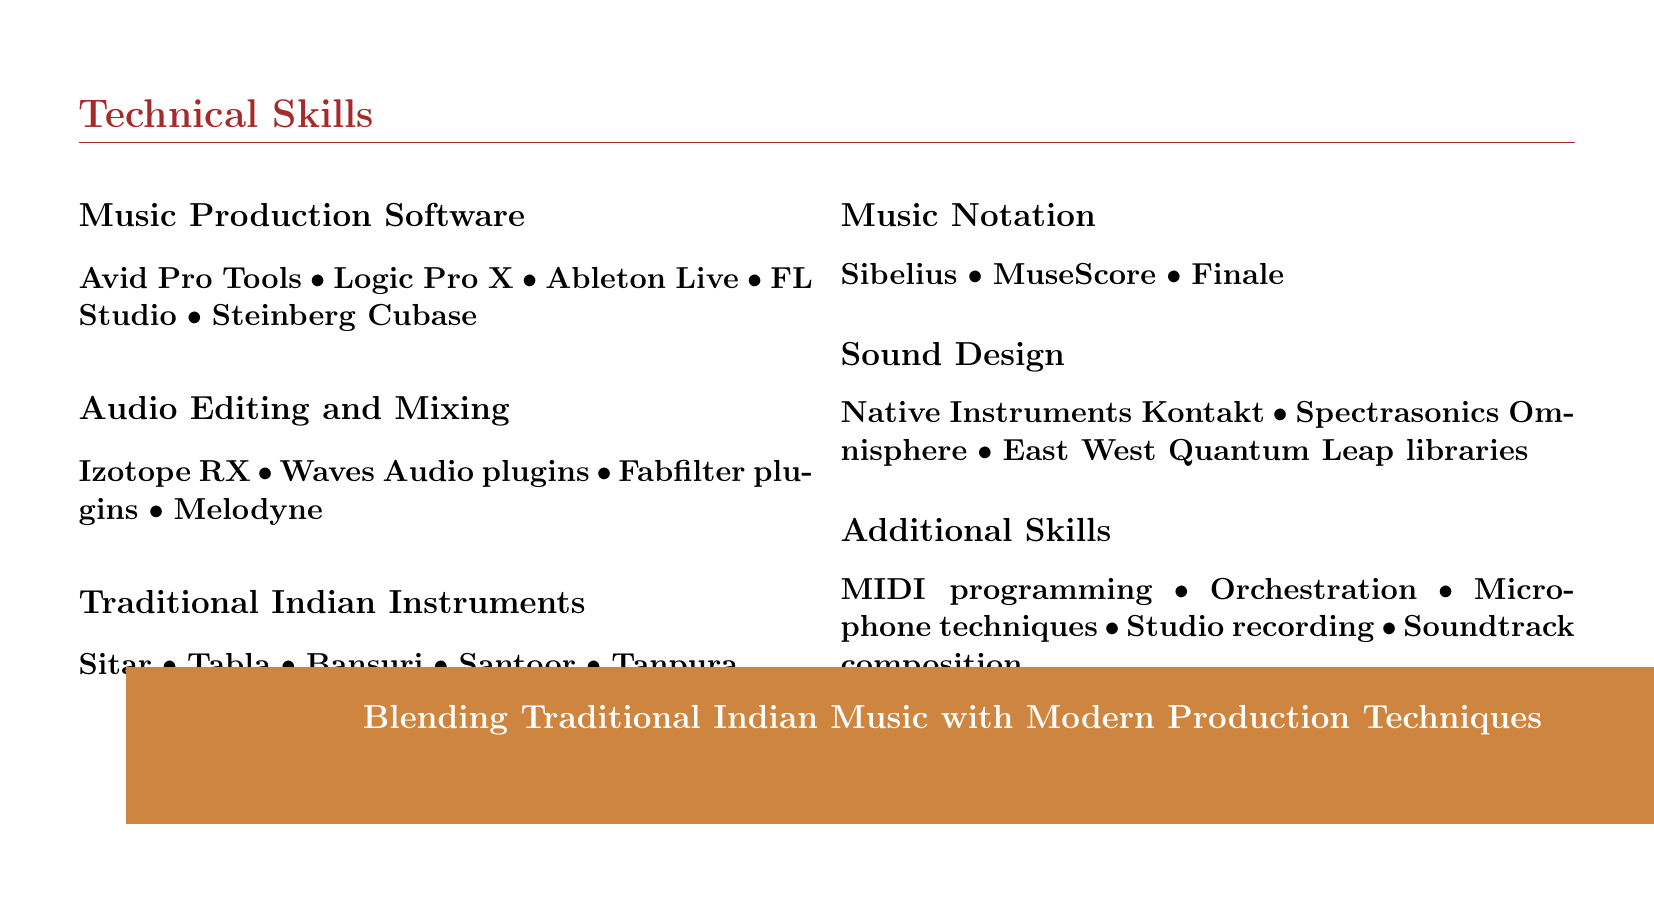what is the title of the document? The title is identified at the top of the document and describes the professional role of the individual.
Answer: Movie Soundtrack Producer how many categories of technical skills are listed? The number of categories is given in the technical skills section of the document.
Answer: 6 which software is mentioned under Music Production Software? This information is found under the Music Production Software section of the technical skills.
Answer: Avid Pro Tools, Logic Pro X, Ableton Live, FL Studio, Steinberg Cubase name one traditional Indian instrument listed in the document. The document includes various traditional Indian instruments under a specific category in the technical skills section.
Answer: Sitar what additional skill involves composing for media? This skill is mentioned in the Additional Skills section and relates directly to producing music for films.
Answer: Soundtrack composition which sound design tool is included in the document? This tool is listed in the Sound Design section of the technical skills.
Answer: Native Instruments Kontakt what two types of audio editing software are mentioned? The question asks for two names found in the Audio Editing and Mixing section.
Answer: Izotope RX, Waves Audio plugins how does the document describe the blending of music styles? This phrase is presented at the bottom of the document, summarizing the individual’s approach.
Answer: Blending Traditional Indian Music with Modern Production Techniques 